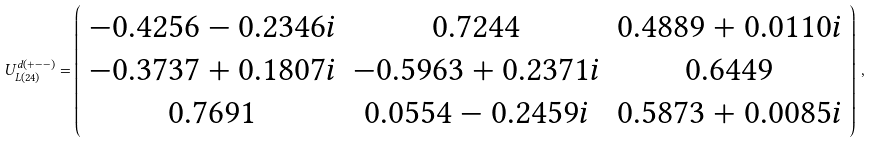Convert formula to latex. <formula><loc_0><loc_0><loc_500><loc_500>U _ { L ( 2 4 ) } ^ { d ( + - - ) } = \left ( \begin{array} { c c c } - 0 . 4 2 5 6 - 0 . 2 3 4 6 i & 0 . 7 2 4 4 & 0 . 4 8 8 9 + 0 . 0 1 1 0 i \\ - 0 . 3 7 3 7 + 0 . 1 8 0 7 i & - 0 . 5 9 6 3 + 0 . 2 3 7 1 i & 0 . 6 4 4 9 \\ 0 . 7 6 9 1 & 0 . 0 5 5 4 - 0 . 2 4 5 9 i & 0 . 5 8 7 3 + 0 . 0 0 8 5 i \end{array} \right ) \, ,</formula> 